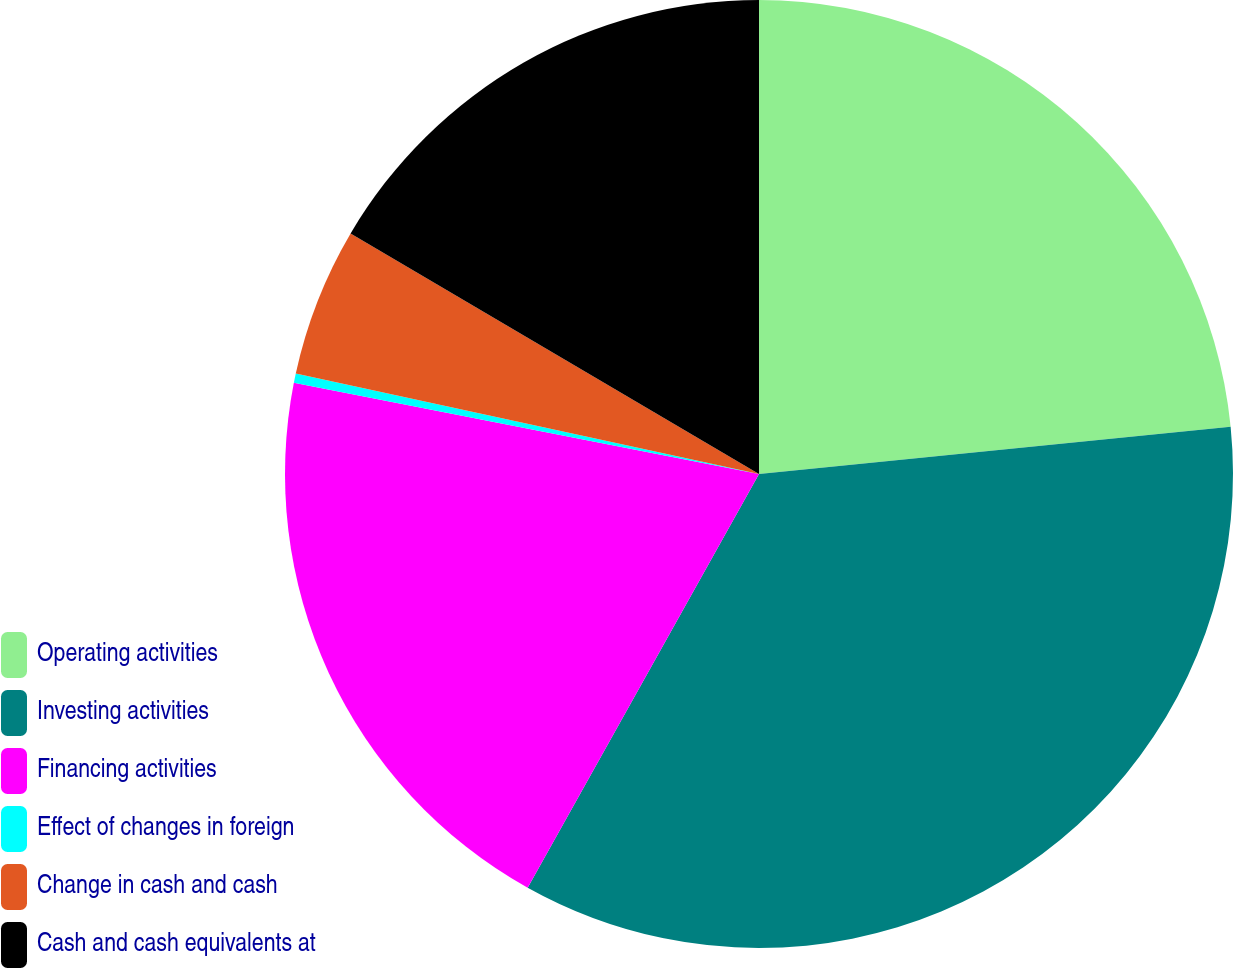Convert chart to OTSL. <chart><loc_0><loc_0><loc_500><loc_500><pie_chart><fcel>Operating activities<fcel>Investing activities<fcel>Financing activities<fcel>Effect of changes in foreign<fcel>Change in cash and cash<fcel>Cash and cash equivalents at<nl><fcel>23.41%<fcel>34.71%<fcel>19.97%<fcel>0.32%<fcel>5.07%<fcel>16.53%<nl></chart> 